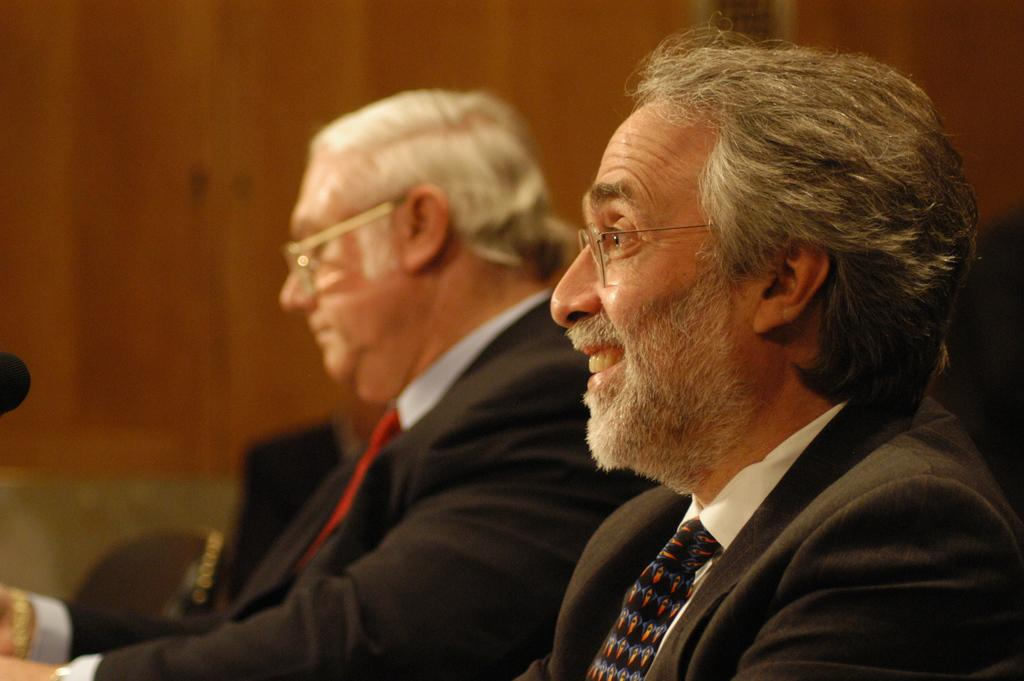How many people are in the image? There are two men in the image. What are the men wearing? The men are wearing coats. What can be seen in front of the men? The men are sitting in front of a mic. Where is the mic located in the image? The mic is on the left side of the image. What can be observed about the background of the image? The background of the image is blurred. How many spiders are crawling on the mic in the image? There are no spiders visible in the image; the focus is on the men and the mic. 